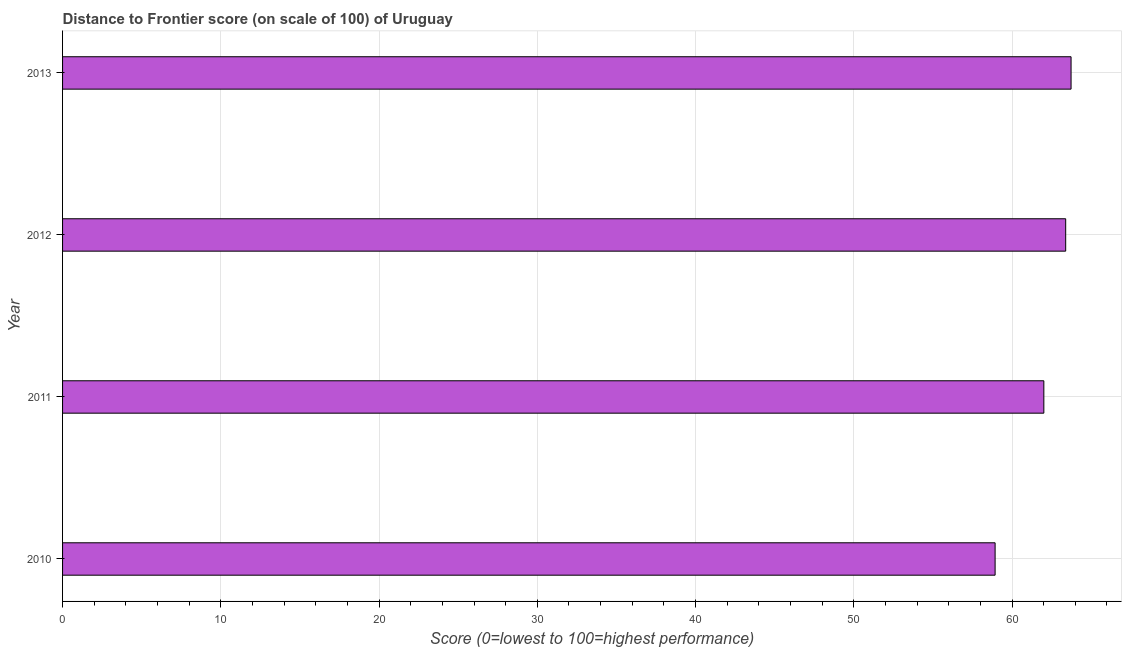Does the graph contain any zero values?
Give a very brief answer. No. What is the title of the graph?
Offer a terse response. Distance to Frontier score (on scale of 100) of Uruguay. What is the label or title of the X-axis?
Provide a succinct answer. Score (0=lowest to 100=highest performance). What is the label or title of the Y-axis?
Give a very brief answer. Year. What is the distance to frontier score in 2010?
Offer a terse response. 58.93. Across all years, what is the maximum distance to frontier score?
Your response must be concise. 63.73. Across all years, what is the minimum distance to frontier score?
Provide a short and direct response. 58.93. What is the sum of the distance to frontier score?
Keep it short and to the point. 248.06. What is the average distance to frontier score per year?
Offer a very short reply. 62.02. What is the median distance to frontier score?
Offer a terse response. 62.7. In how many years, is the distance to frontier score greater than 34 ?
Provide a short and direct response. 4. What is the ratio of the distance to frontier score in 2010 to that in 2011?
Your answer should be compact. 0.95. Is the distance to frontier score in 2010 less than that in 2011?
Your answer should be very brief. Yes. Is the difference between the distance to frontier score in 2012 and 2013 greater than the difference between any two years?
Your answer should be compact. No. What is the difference between the highest and the second highest distance to frontier score?
Your answer should be compact. 0.34. Is the sum of the distance to frontier score in 2010 and 2012 greater than the maximum distance to frontier score across all years?
Ensure brevity in your answer.  Yes. What is the difference between the highest and the lowest distance to frontier score?
Your answer should be compact. 4.8. How many years are there in the graph?
Offer a very short reply. 4. What is the difference between two consecutive major ticks on the X-axis?
Keep it short and to the point. 10. Are the values on the major ticks of X-axis written in scientific E-notation?
Give a very brief answer. No. What is the Score (0=lowest to 100=highest performance) of 2010?
Make the answer very short. 58.93. What is the Score (0=lowest to 100=highest performance) in 2011?
Your answer should be compact. 62.01. What is the Score (0=lowest to 100=highest performance) of 2012?
Give a very brief answer. 63.39. What is the Score (0=lowest to 100=highest performance) of 2013?
Keep it short and to the point. 63.73. What is the difference between the Score (0=lowest to 100=highest performance) in 2010 and 2011?
Ensure brevity in your answer.  -3.08. What is the difference between the Score (0=lowest to 100=highest performance) in 2010 and 2012?
Provide a short and direct response. -4.46. What is the difference between the Score (0=lowest to 100=highest performance) in 2010 and 2013?
Keep it short and to the point. -4.8. What is the difference between the Score (0=lowest to 100=highest performance) in 2011 and 2012?
Give a very brief answer. -1.38. What is the difference between the Score (0=lowest to 100=highest performance) in 2011 and 2013?
Give a very brief answer. -1.72. What is the difference between the Score (0=lowest to 100=highest performance) in 2012 and 2013?
Make the answer very short. -0.34. What is the ratio of the Score (0=lowest to 100=highest performance) in 2010 to that in 2011?
Provide a short and direct response. 0.95. What is the ratio of the Score (0=lowest to 100=highest performance) in 2010 to that in 2013?
Provide a succinct answer. 0.93. What is the ratio of the Score (0=lowest to 100=highest performance) in 2011 to that in 2012?
Ensure brevity in your answer.  0.98. What is the ratio of the Score (0=lowest to 100=highest performance) in 2012 to that in 2013?
Your answer should be very brief. 0.99. 